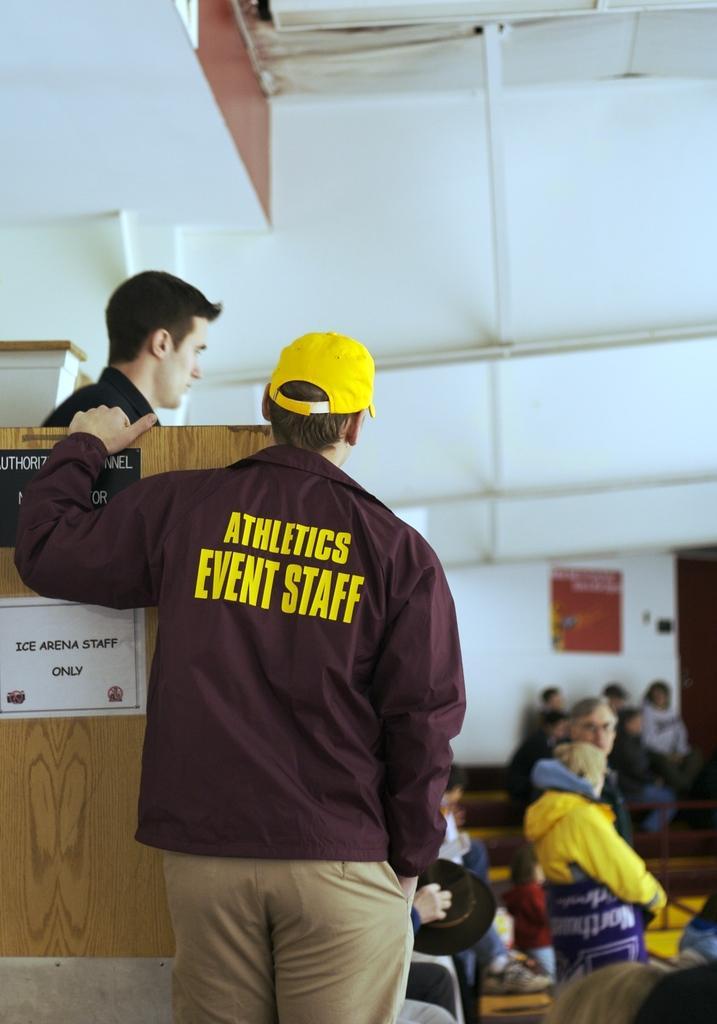How would you summarize this image in a sentence or two? In this image I can see a person wearing jacket, pant and yellow color cap is standing. In the background I can see a person wearing black shirt is standing behind the cream colored board, few other persons, the white colored wall and few other objects. 